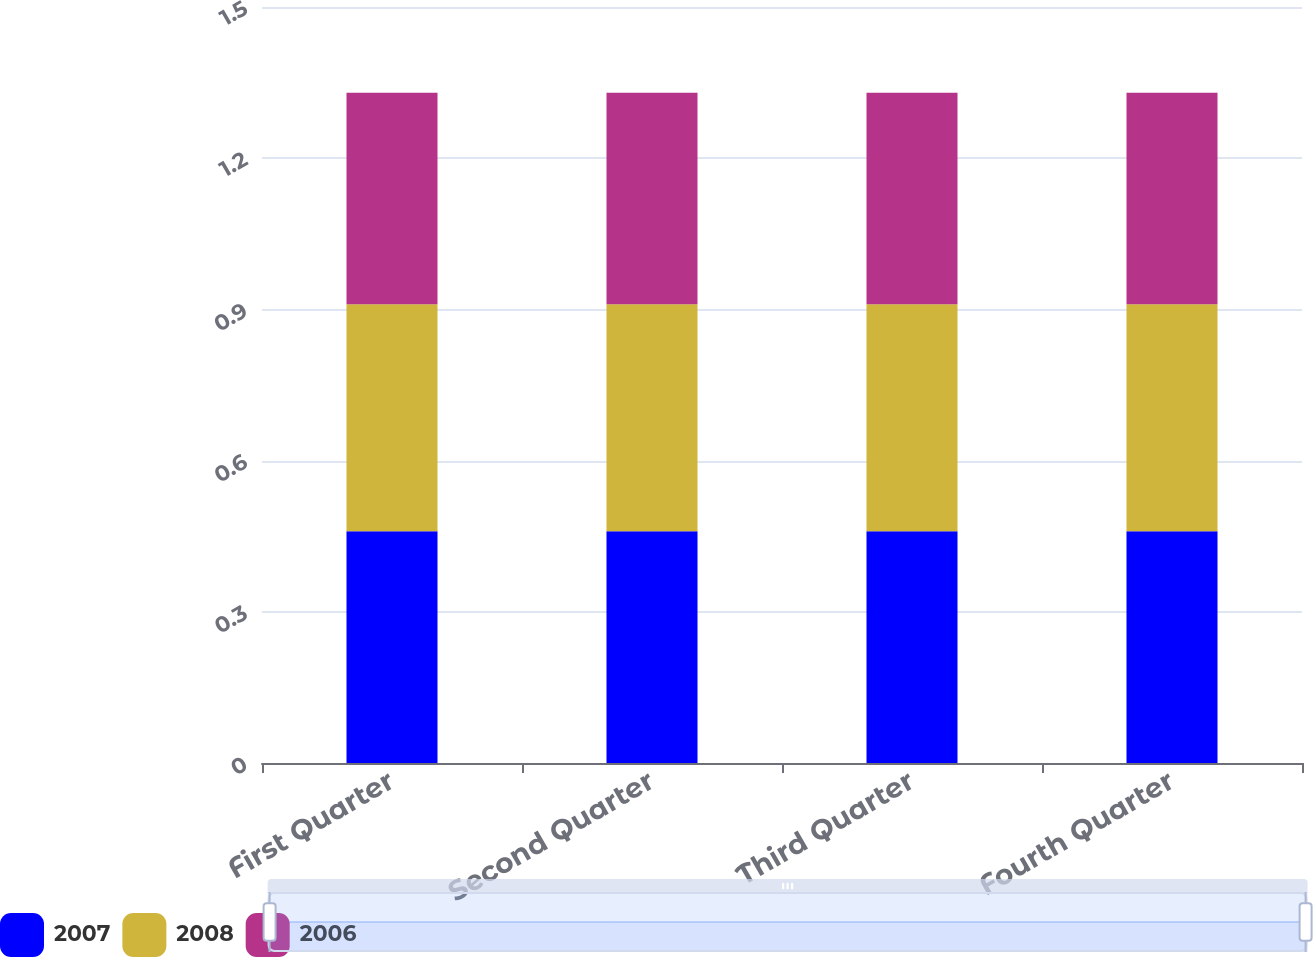Convert chart to OTSL. <chart><loc_0><loc_0><loc_500><loc_500><stacked_bar_chart><ecel><fcel>First Quarter<fcel>Second Quarter<fcel>Third Quarter<fcel>Fourth Quarter<nl><fcel>2007<fcel>0.46<fcel>0.46<fcel>0.46<fcel>0.46<nl><fcel>2008<fcel>0.45<fcel>0.45<fcel>0.45<fcel>0.45<nl><fcel>2006<fcel>0.42<fcel>0.42<fcel>0.42<fcel>0.42<nl></chart> 